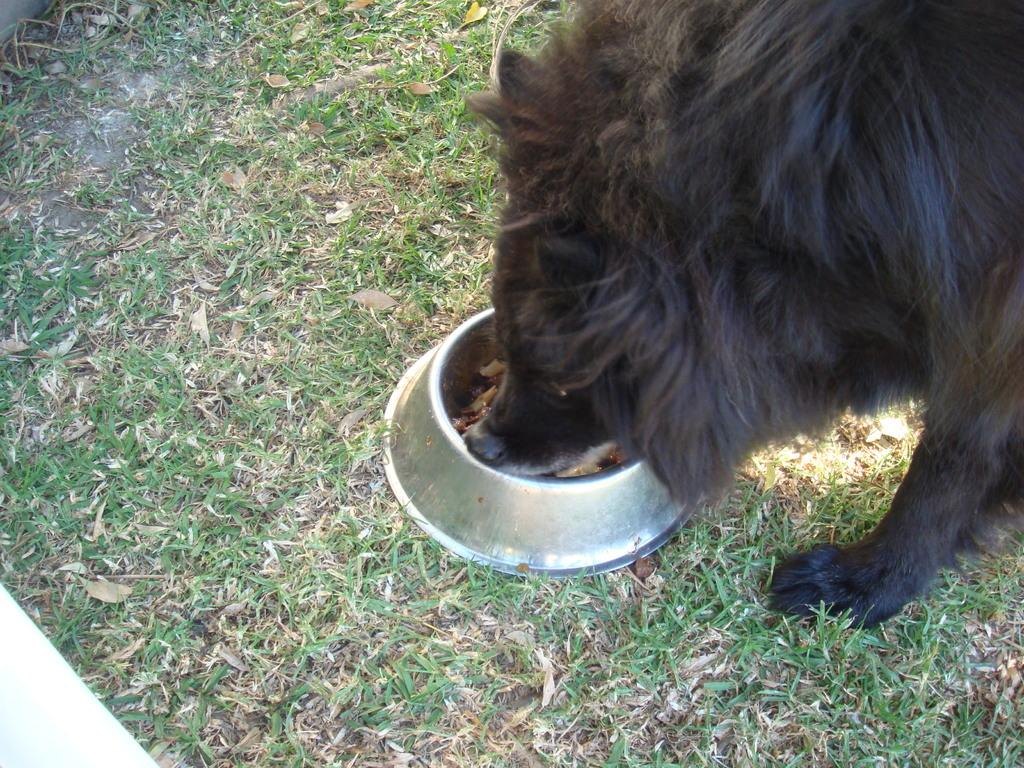What type of environment is depicted in the image? There is a grassland in the image. What object can be seen on the grassland? There is a bowl on the grassland. What is inside the bowl? There is food in the bowl. What animal is present in the image? There is a black dog in the image. What is the black dog doing in the image? The black dog is eating the food. Where is the bomb located in the image? There is no bomb present in the image. What story is the black dog telling in the image? The image does not depict the black dog telling a story; it shows the dog eating food from a bowl. 